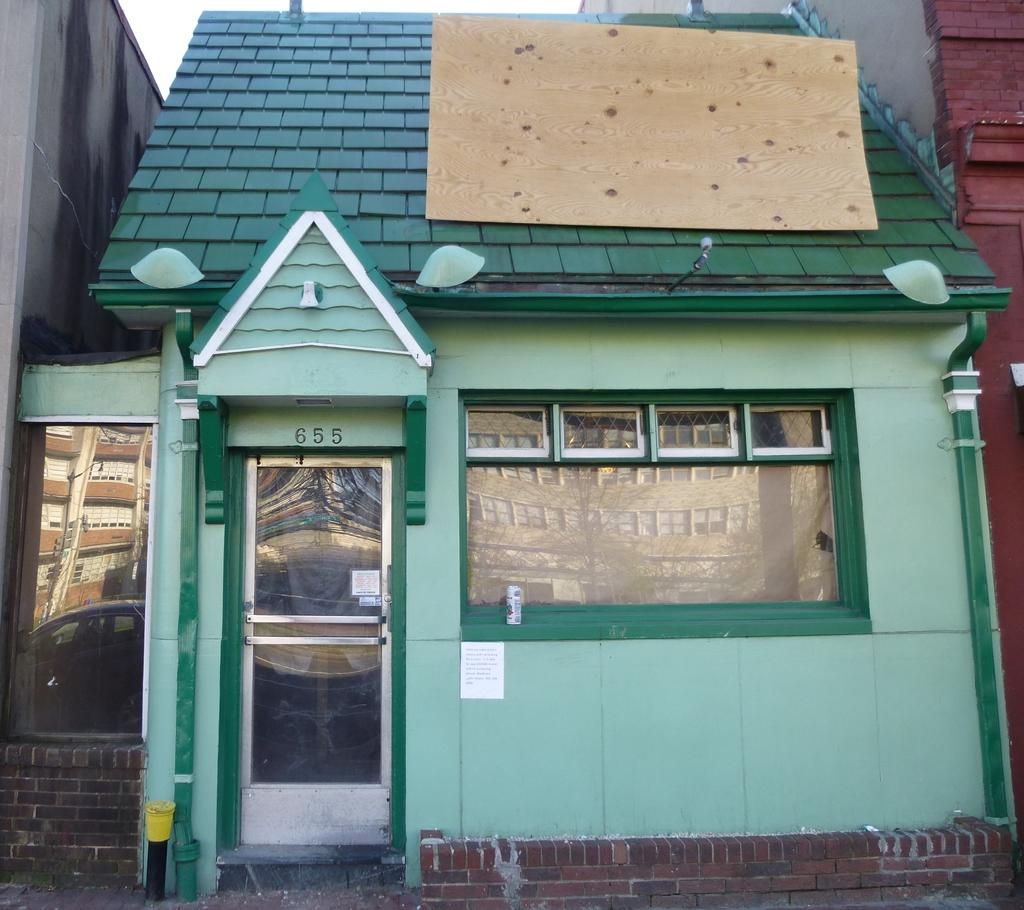What type of structure is in the image? There is a small house in the image. What feature can be seen on the house? There is a glass door on the house. Are there any openings for light and ventilation in the house? Yes, there are windows on the house. What is visible at the top of the image? The sky is visible at the top of the image. Where is the map located in the image? There is no map present in the image. What type of boot can be seen near the house in the image? There is no boot visible in the image. 